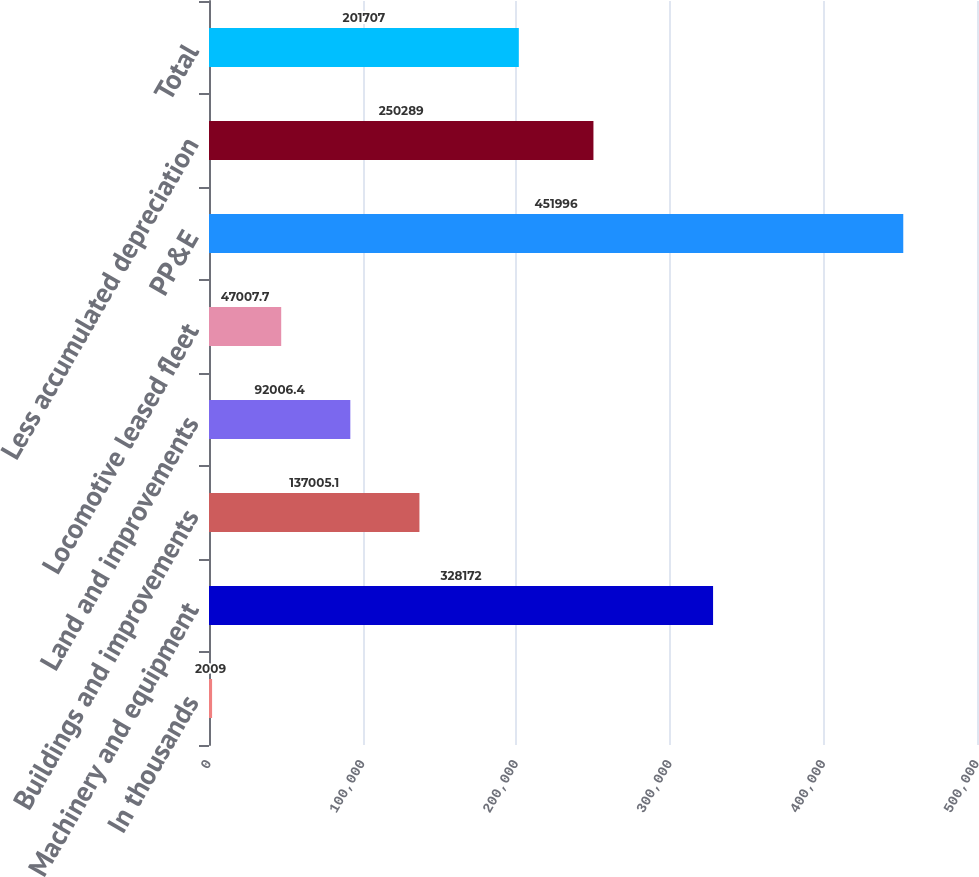<chart> <loc_0><loc_0><loc_500><loc_500><bar_chart><fcel>In thousands<fcel>Machinery and equipment<fcel>Buildings and improvements<fcel>Land and improvements<fcel>Locomotive leased fleet<fcel>PP&E<fcel>Less accumulated depreciation<fcel>Total<nl><fcel>2009<fcel>328172<fcel>137005<fcel>92006.4<fcel>47007.7<fcel>451996<fcel>250289<fcel>201707<nl></chart> 